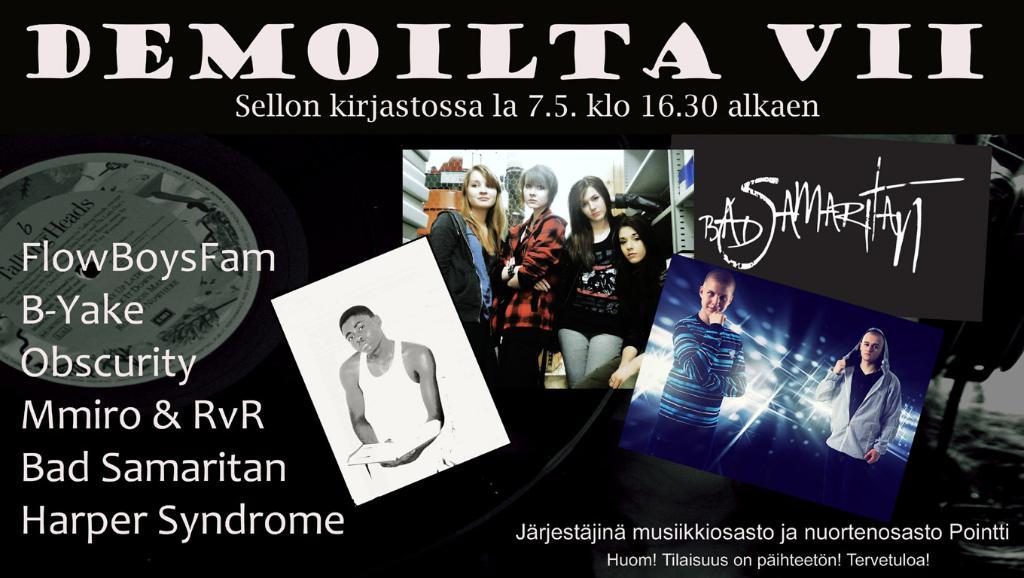Will bad samaritan be at demoilta vii?
Keep it short and to the point. Yes. 